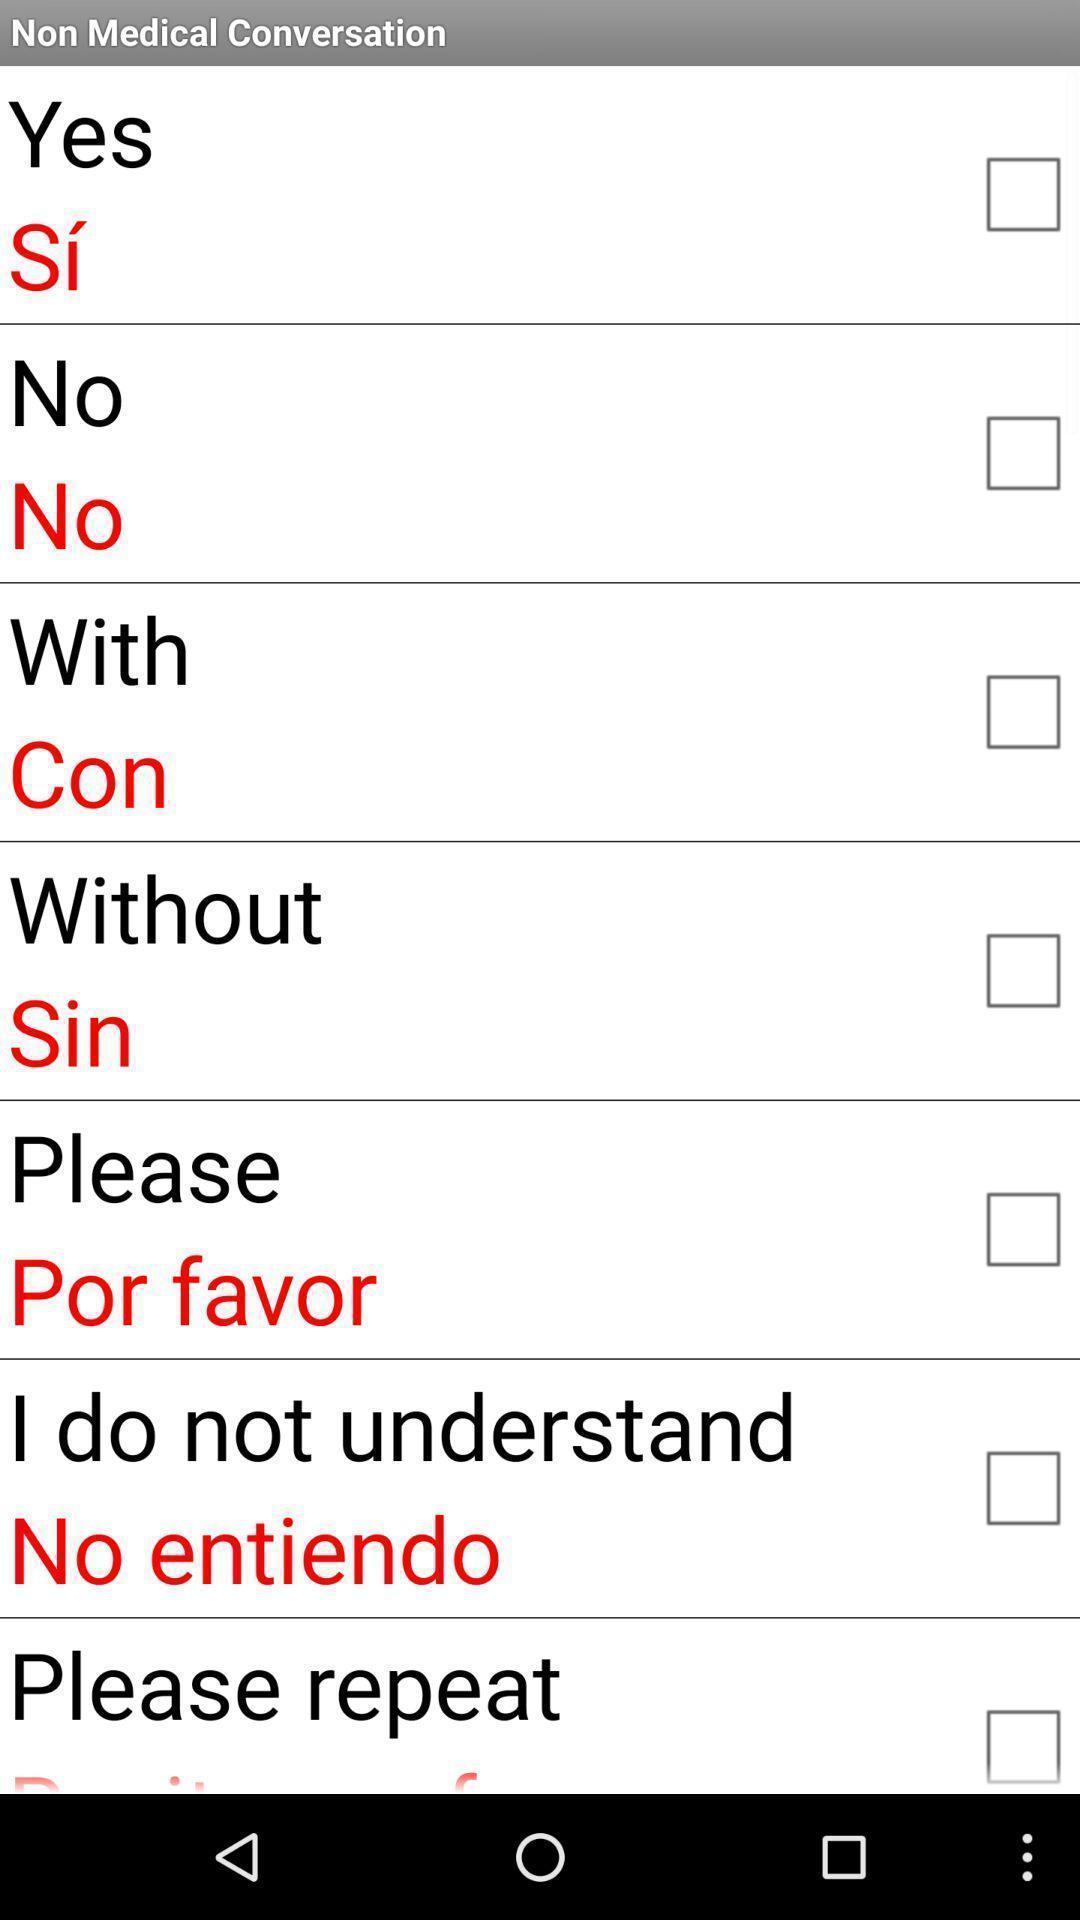Explain the elements present in this screenshot. Page showing different options. 